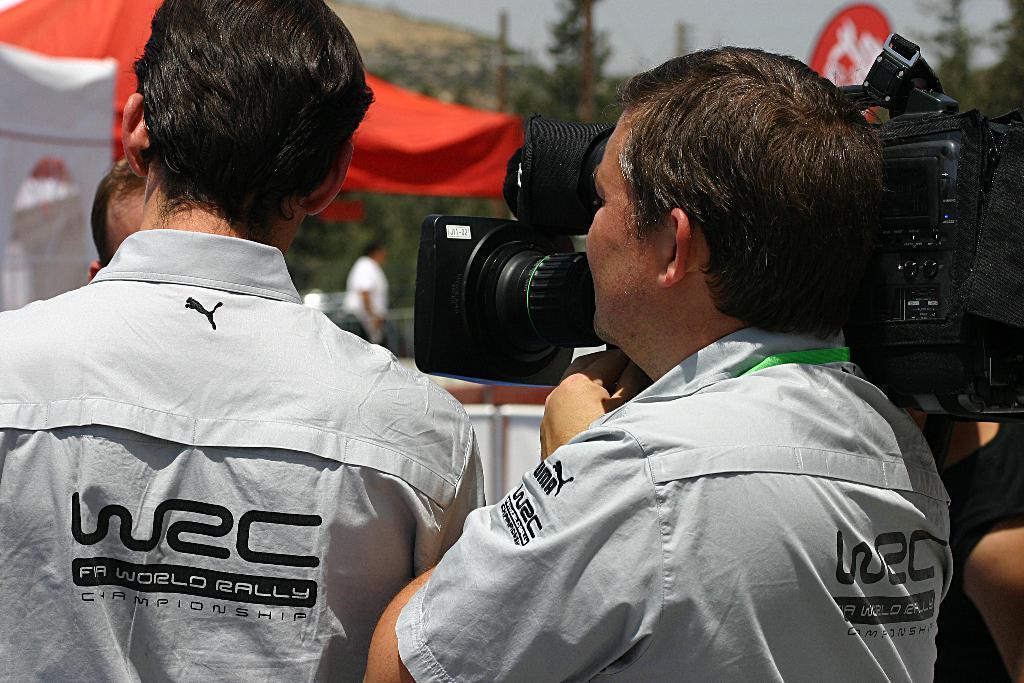Can you describe this image briefly? Front this two persons are standing and wore white shirts. This man is holding a camera. Far there are number of trees and tent in red color. 